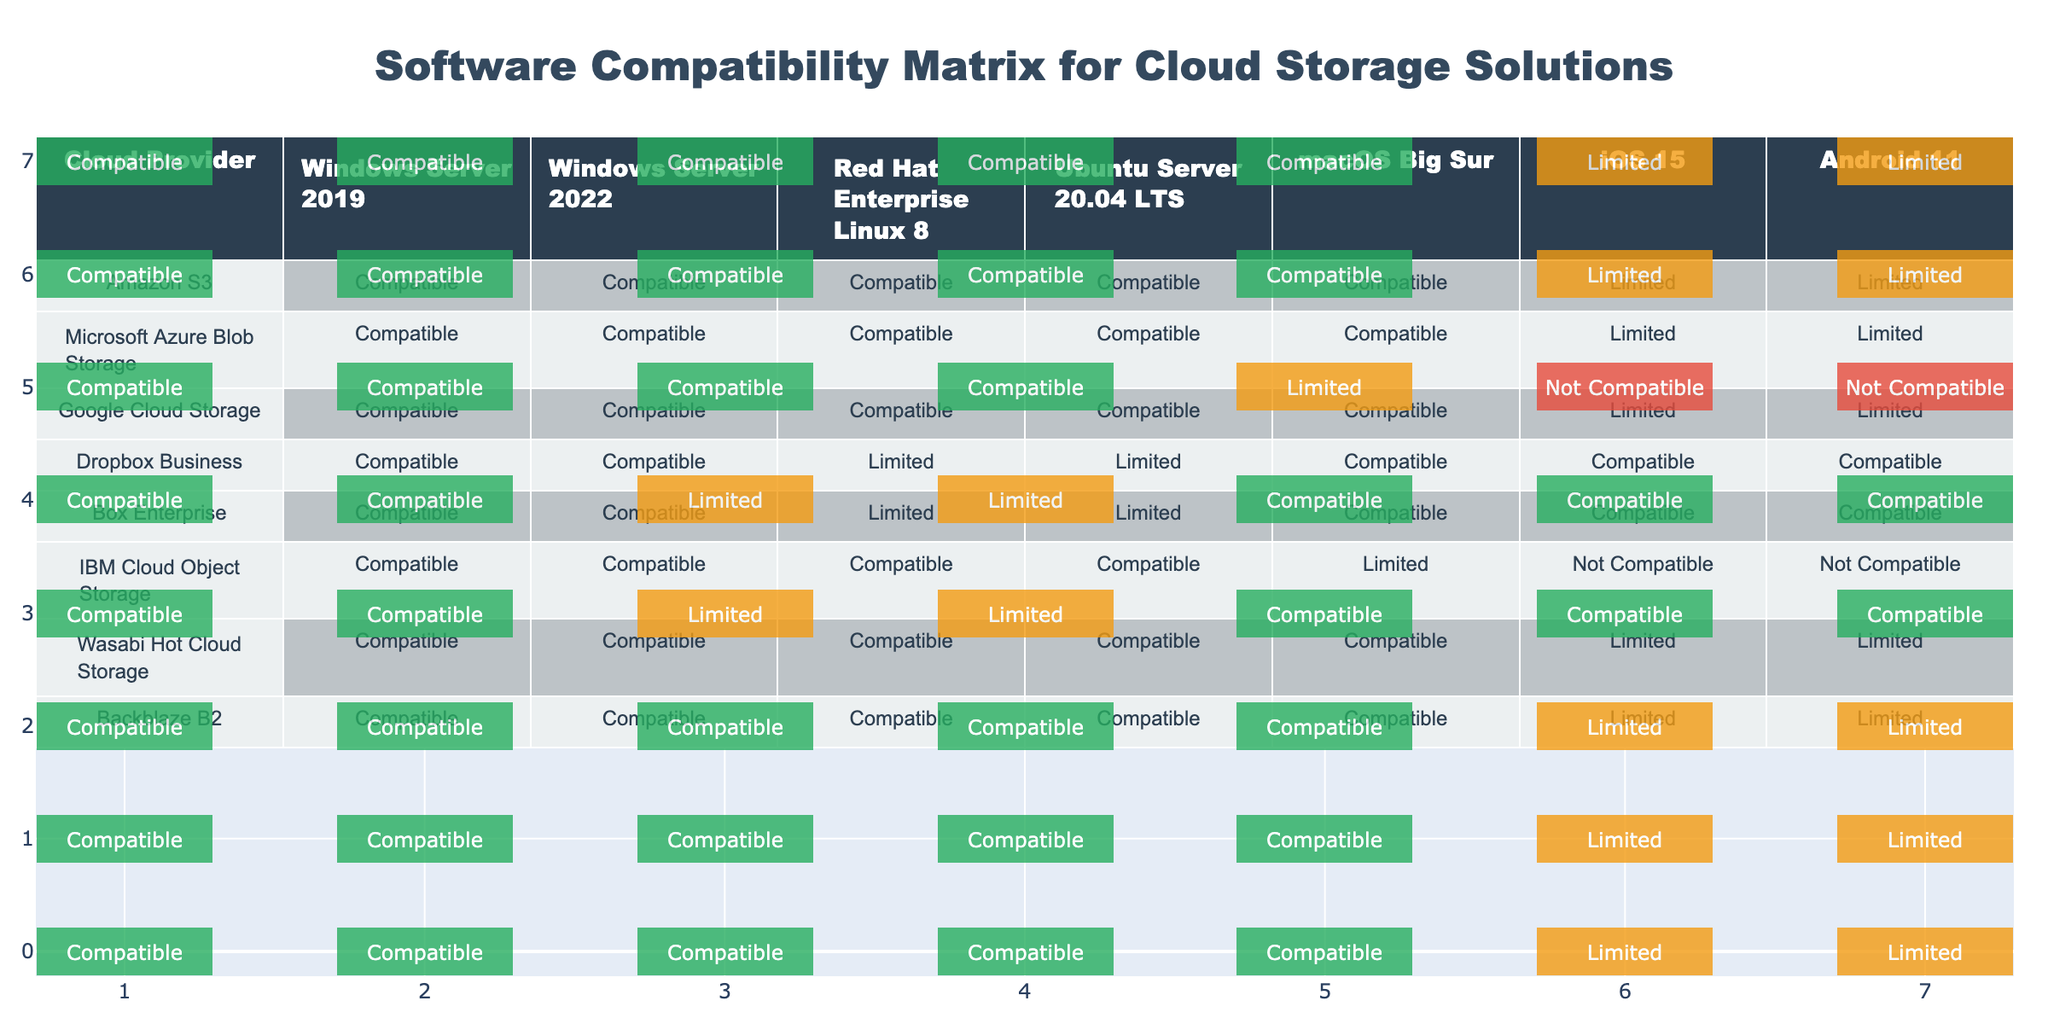What is the compatibility status of Amazon S3 with Windows Server 2022? The table shows that Amazon S3 is marked as "Compatible" under the column for Windows Server 2022.
Answer: Compatible Is IBM Cloud Object Storage compatible with macOS Big Sur? According to the table, IBM Cloud Object Storage has a compatibility status of "Limited" with macOS Big Sur.
Answer: Limited How many cloud providers are compatible with Ubuntu Server 20.04 LTS? By counting the entries under the Ubuntu Server 20.04 LTS column, I find that there are six providers (Amazon S3, Microsoft Azure Blob Storage, Google Cloud Storage, Wasabi Hot Cloud Storage, Backblaze B2) labeled as "Compatible."
Answer: 6 Is Dropbox Business better than Google Cloud Storage for iOS 15 compatibility? Both Dropbox Business and Google Cloud Storage have a compatibility status of "Limited" for iOS 15 according to the table. Therefore, neither is better as they share the same compatibility rating.
Answer: No Which cloud provider has the most "Not Compatible" statuses in the table? By looking through the compatibility statuses, I see that IBM Cloud Object Storage has "Not Compatible" ratings twice (for iOS 15 and Android 11), which is more than any other provider.
Answer: IBM Cloud Object Storage What is the total number of cloud providers that are fully compatible (i.e., compatible across all platforms)? Upon examining the table, I find that the cloud providers Amazon S3, Microsoft Azure Blob Storage, Google Cloud Storage, Wasabi Hot Cloud Storage, and Backblaze B2 are all "Compatible" across all platforms, making a total of five.
Answer: 5 For which operating system does Box Enterprise have a "Not Compatible" status? Reviewing the Box Enterprise row in the table reveals that it does not have a "Not Compatible" status with any operating system, meaning all statuses are either "Compatible" or "Limited."
Answer: None How does the compatibility of Windows Server 2019 compare to Windows Server 2022 for all providers? Both Windows Server 2019 and Windows Server 2022 show "Compatible" status for all providers except IBM Cloud Object Storage, where it is "Limited" for Windows Server 2022, indicating a single point of difference.
Answer: One difference with IBM Cloud Object Storage Is there any cloud provider that is entirely compatible with mobile operating systems (iOS 15 and Android 11)? By assessing the compatibility statuses for mobile operating systems, I find that no provider shows "Compatible" for both iOS 15 and Android 11, indicating that all have limitations or incompatibilities.
Answer: No 